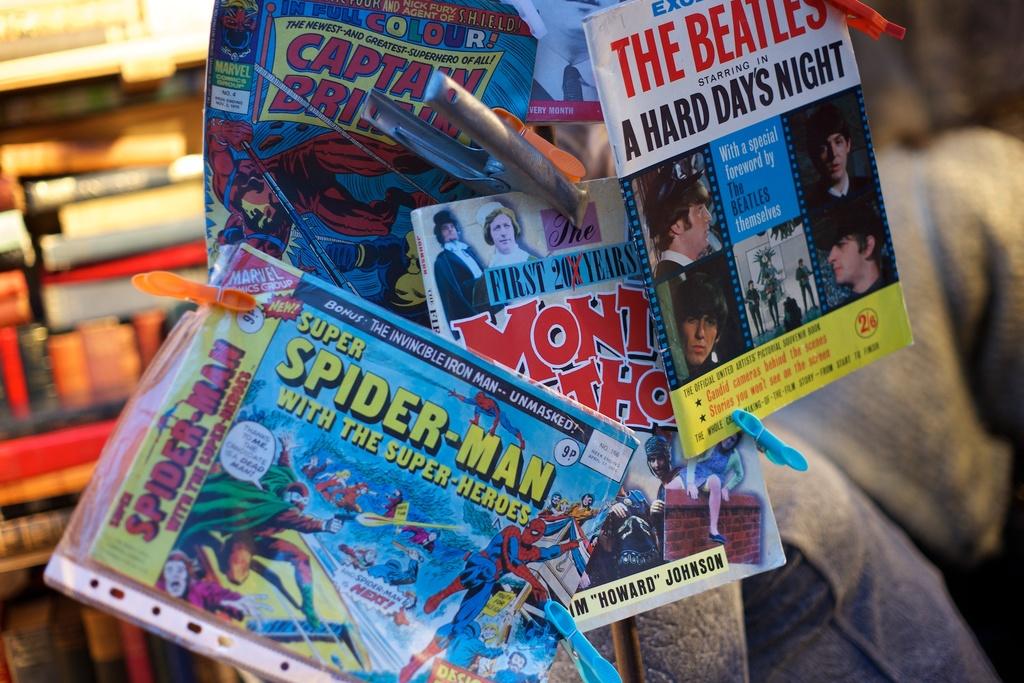Who is with the super-heroes?
Provide a short and direct response. Spider-man. What band is on the magazine on the top right?
Your answer should be very brief. The beatles. 